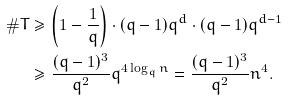<formula> <loc_0><loc_0><loc_500><loc_500>\# T & \geq \left ( 1 - \frac { 1 } { q } \right ) \cdot ( q - 1 ) q ^ { d } \cdot ( q - 1 ) q ^ { d - 1 } \\ & \geq \frac { ( q - 1 ) ^ { 3 } } { q ^ { 2 } } q ^ { 4 \log _ { q } n } = \frac { ( q - 1 ) ^ { 3 } } { q ^ { 2 } } n ^ { 4 } .</formula> 